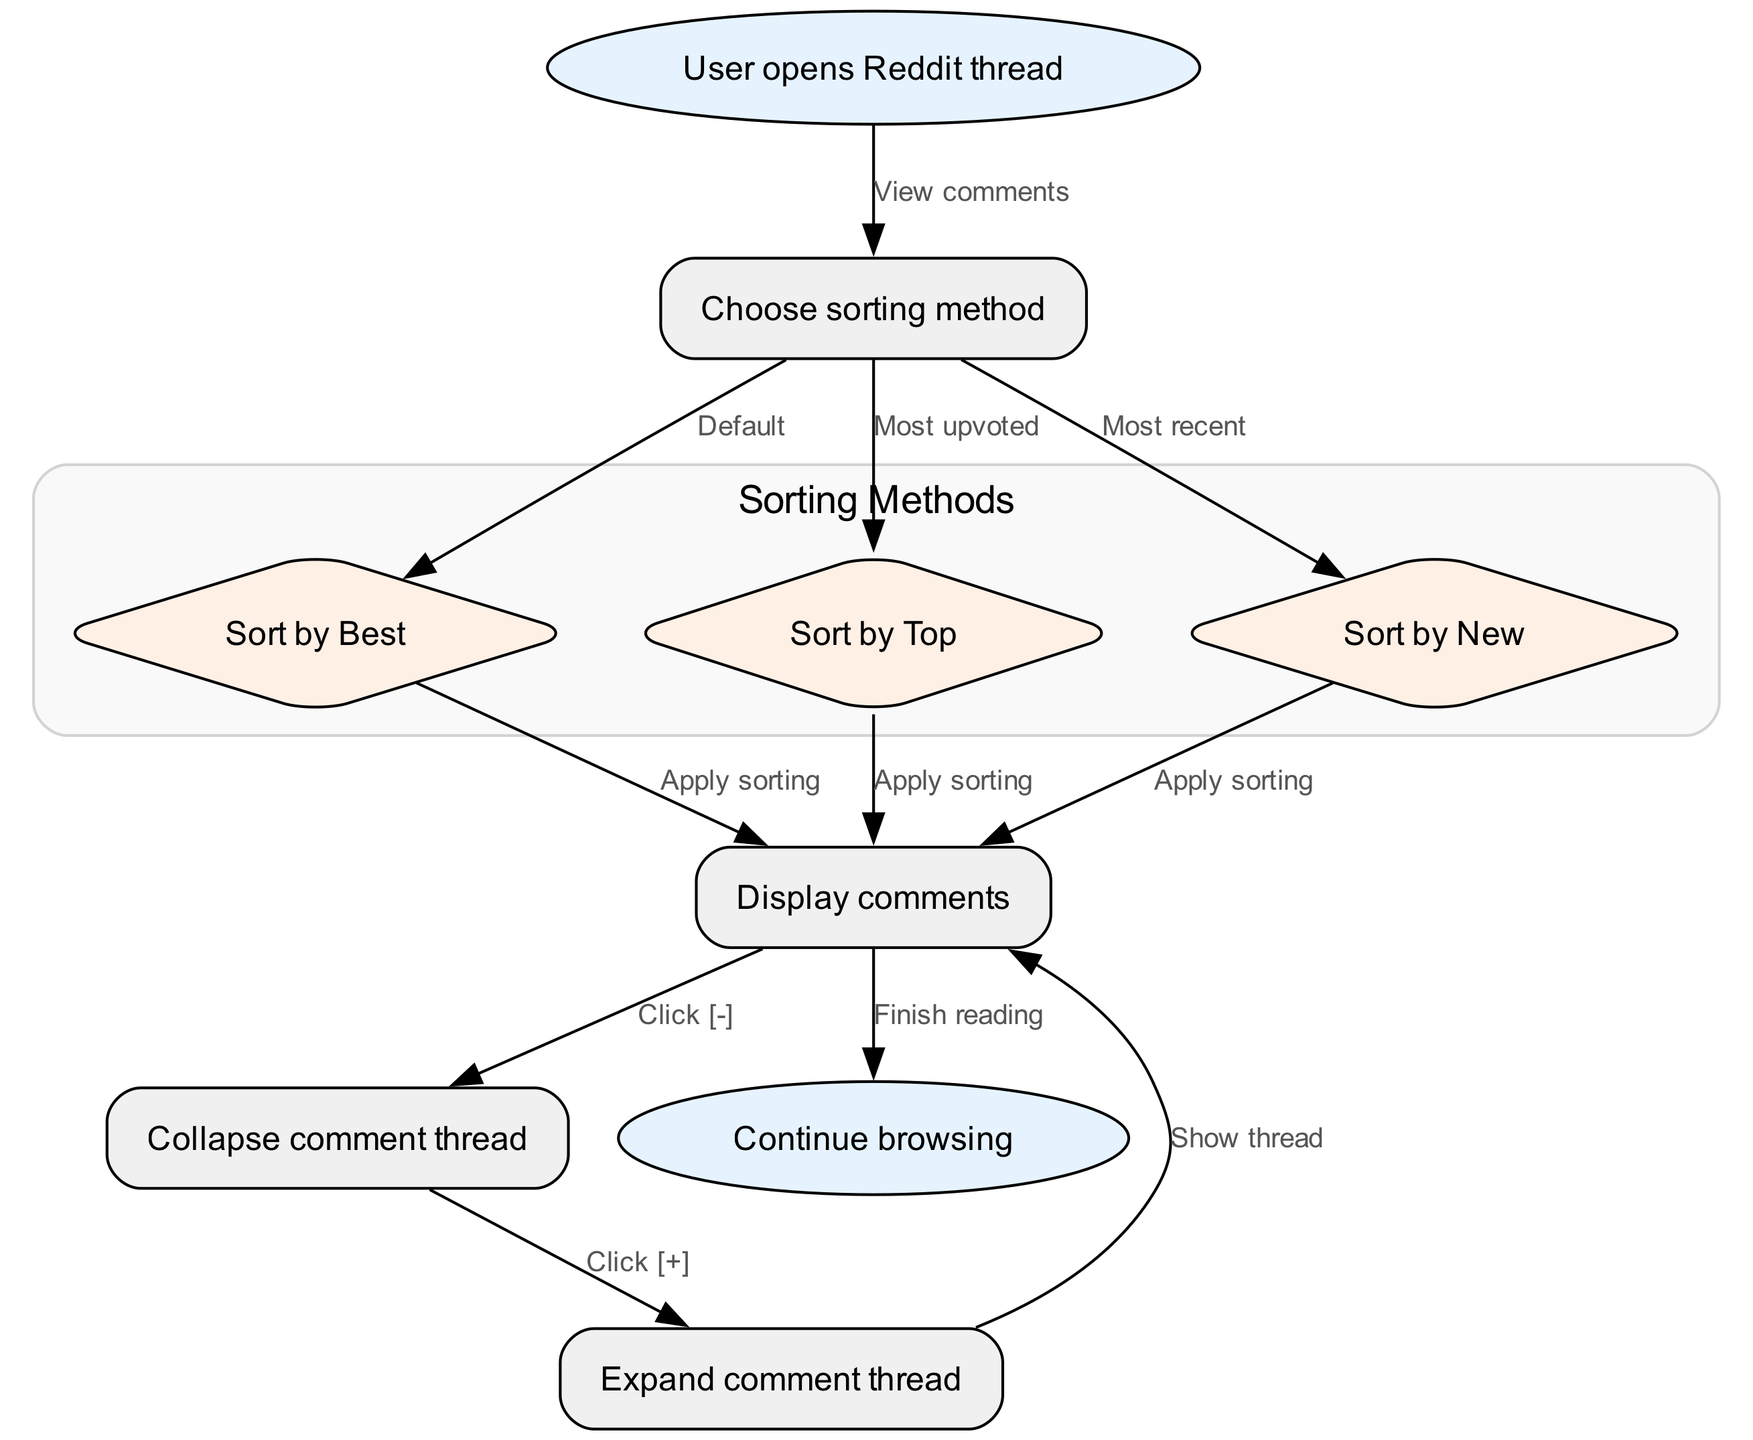What is the first action a user takes when opening a Reddit thread? The first action in the diagram is represented by the "start" node, which states that the user opens the Reddit thread. This initiates the flow of the process outlined in the diagram.
Answer: User opens Reddit thread How many sorting methods are available in the diagram? The diagram includes three sorting methods: Best, Top, and New. This is determined by counting the nodes leading from the "sort" node, specifically the "best," "top," and "new" nodes.
Answer: 3 What happens after sorting by Top? After sorting by Top, the flow goes to the "display" node, where comments are displayed. This follows the edge that leads from the "top" node to the "display" node, indicating that applying the sorting results in displaying comments.
Answer: Display comments What action results in the collapse of the comment thread? The action that leads to the collapse of the comment thread is represented by the edge from the "display" node to the "collapse" node, initiated by clicking the "[-]" symbol. This indicates that the comment thread is collapsed when a user selects this option.
Answer: Collapse comment thread What must a user do to read the collapsed comments again? To read the collapsed comments again, the user must click the "[+]" symbol, which is indicated by the edge leading from the "collapse" node to the "expand" node. This step involves expanding the comment thread to view it again.
Answer: Expand comment thread Which node indicates the end of the browsing process? The node that indicates the end of the browsing process is the "end" node. The flow leads from the "display" node to the "end" node after one finishes reading comments, marking the conclusion of the user's action in the thread.
Answer: Continue browsing 